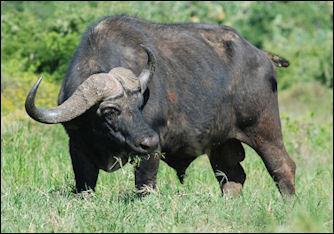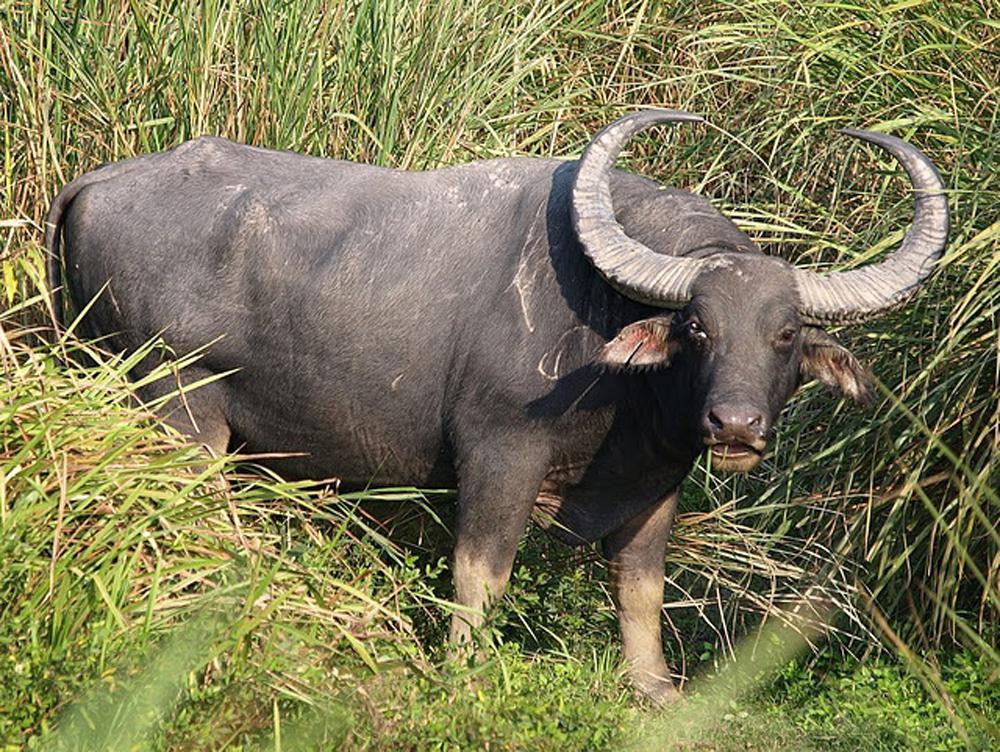The first image is the image on the left, the second image is the image on the right. For the images displayed, is the sentence "In one of the image a water buffalo is standing in the water." factually correct? Answer yes or no. No. The first image is the image on the left, the second image is the image on the right. Examine the images to the left and right. Is the description "At least one image shows a buffalo in the water." accurate? Answer yes or no. No. 